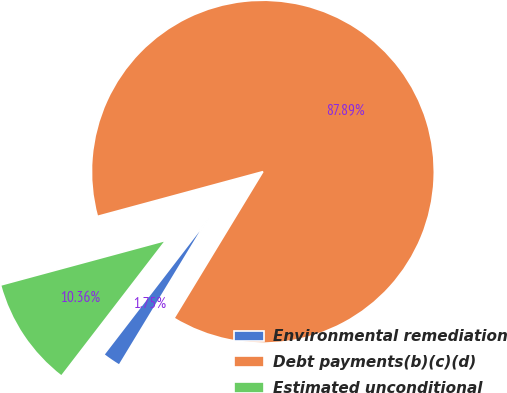Convert chart. <chart><loc_0><loc_0><loc_500><loc_500><pie_chart><fcel>Environmental remediation<fcel>Debt payments(b)(c)(d)<fcel>Estimated unconditional<nl><fcel>1.75%<fcel>87.88%<fcel>10.36%<nl></chart> 